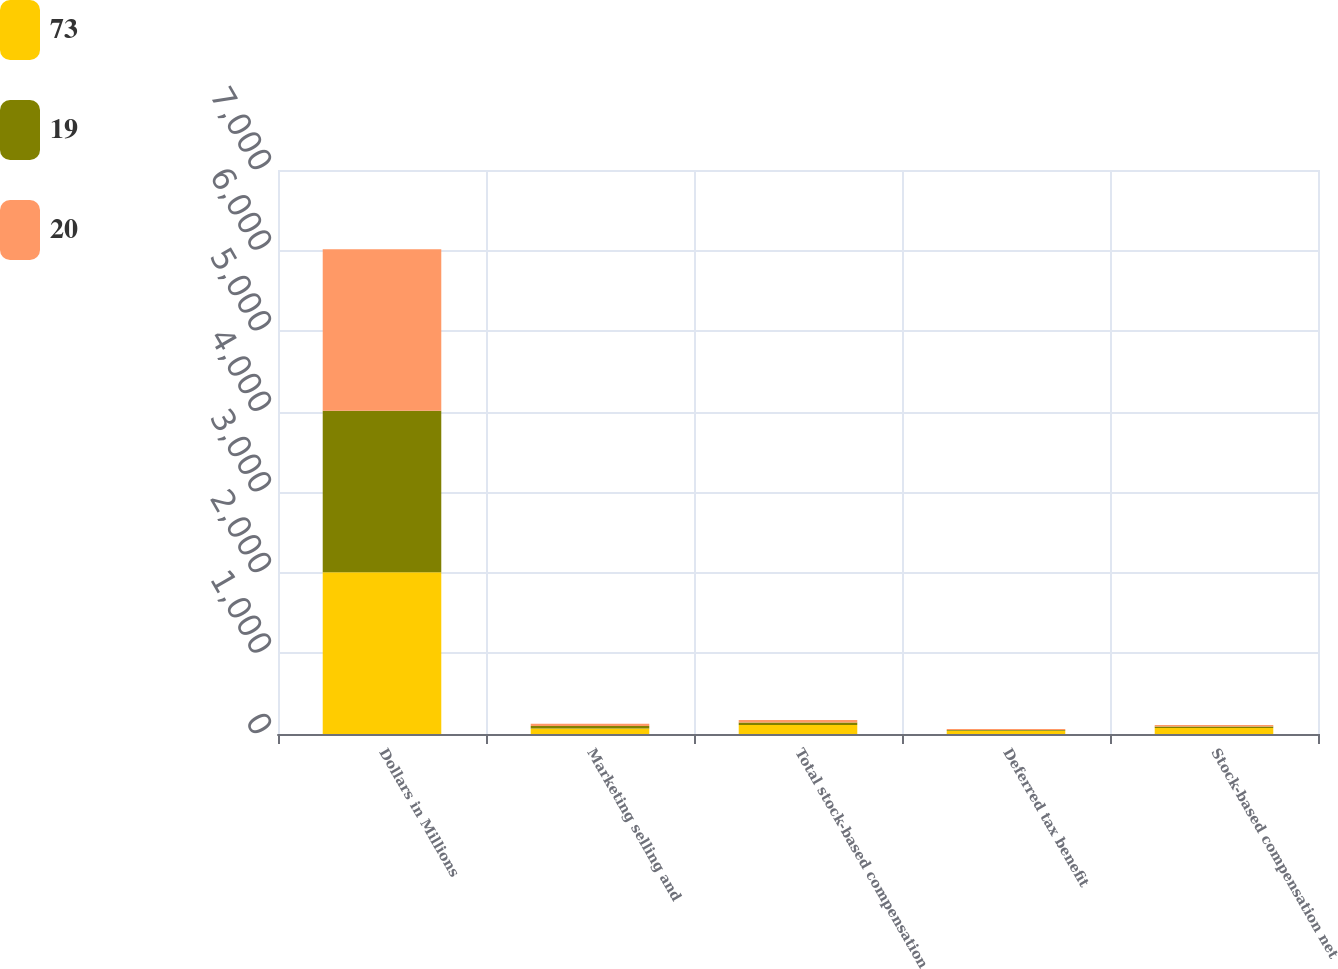Convert chart. <chart><loc_0><loc_0><loc_500><loc_500><stacked_bar_chart><ecel><fcel>Dollars in Millions<fcel>Marketing selling and<fcel>Total stock-based compensation<fcel>Deferred tax benefit<fcel>Stock-based compensation net<nl><fcel>73<fcel>2006<fcel>67<fcel>112<fcel>39<fcel>73<nl><fcel>19<fcel>2005<fcel>31<fcel>31<fcel>11<fcel>20<nl><fcel>20<fcel>2004<fcel>30<fcel>30<fcel>11<fcel>19<nl></chart> 